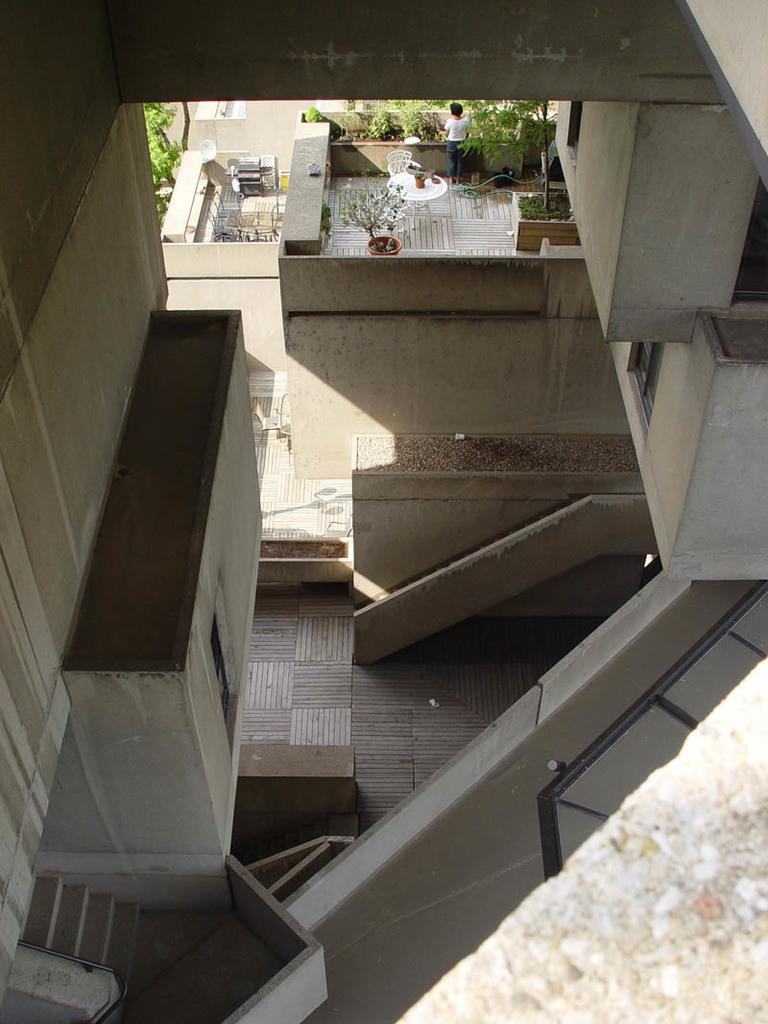Can you describe this image briefly? In this picture I can see there is a person standing on the roof and there are plants on the roof. There is a building here and there are stairs. 